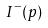Convert formula to latex. <formula><loc_0><loc_0><loc_500><loc_500>I ^ { - } ( p )</formula> 